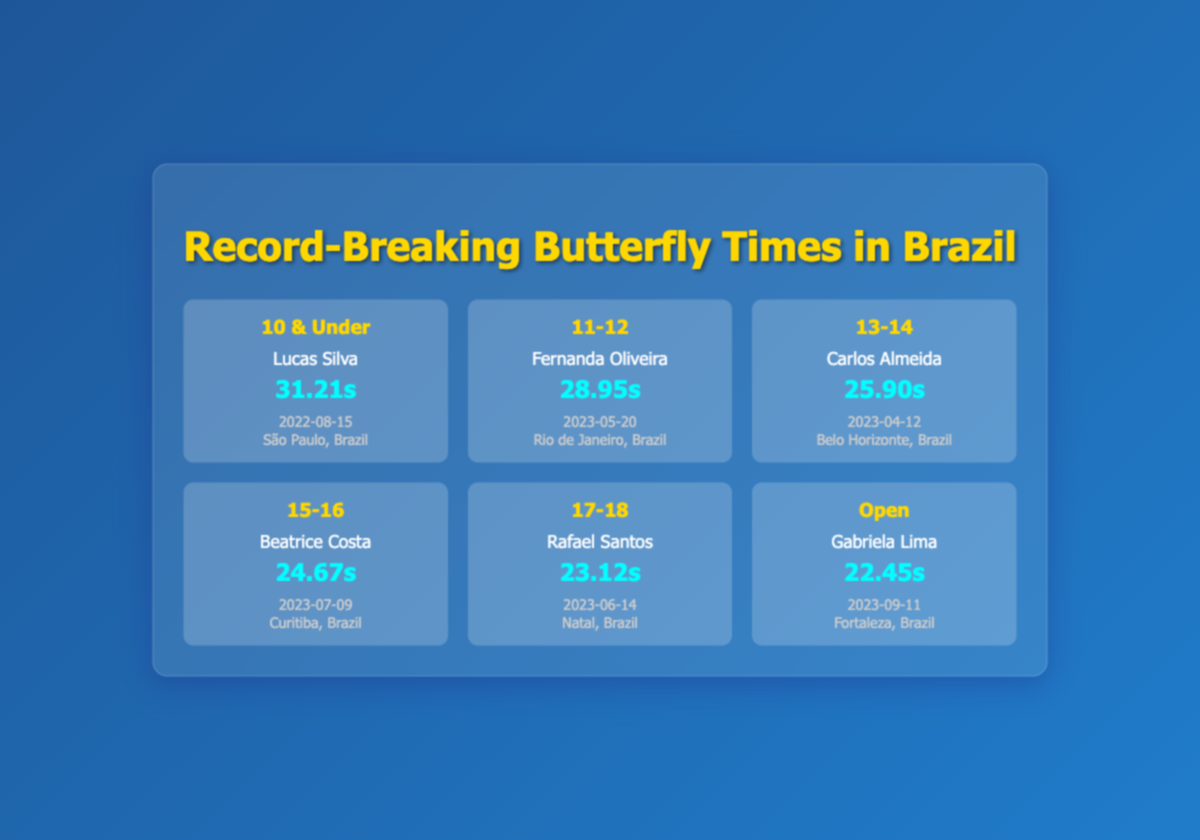What is the record time for the 10 & Under age category? The table shows that the record time for the 10 & Under age category is 31.21 seconds. This information is explicitly stated in the record for Lucas Silva.
Answer: 31.21 seconds Who holds the record for the Open age category? According to the table, Gabriela Lima holds the record for the Open age category. This is clearly indicated under the respective row for that age category.
Answer: Gabriela Lima What is the difference in record times between the 15-16 and 17-18 age categories? The record time for the 15-16 age category is 24.67 seconds, and for the 17-18 age category, it is 23.12 seconds. The difference is calculated by subtracting the latter from the former: 24.67 - 23.12 = 1.55 seconds.
Answer: 1.55 seconds Is the record time for the 11-12 age category faster than that of the 13-14 age category? The table indicates that the record time for the 11-12 age category is 28.95 seconds, while for the 13-14 age category, it is 25.90 seconds. Since 28.95 seconds is greater than 25.90 seconds, the 11-12 age category record is not faster.
Answer: No What is the average record time across all age categories? First, we sum the record times of all categories: 31.21 + 28.95 + 25.90 + 24.67 + 23.12 + 22.45 = 156.30 seconds. Then, we divide by the number of categories, which is 6: 156.30 / 6 = 26.05 seconds.
Answer: 26.05 seconds Who has the fastest butterfly stroke record? The table shows that Gabriela Lima has the fastest record in the Open category with a time of 22.45 seconds, which is the lowest time listed in all categories.
Answer: Gabriela Lima What was the event date for Carlos Almeida’s record? The record for Carlos Almeida under the 13-14 age category states that the event date was 2023-04-12. This specific detail is directly available in the respective row.
Answer: 2023-04-12 Which event location had the fastest record time? By reviewing the table, Gabriela Lima’s record of 22.45 seconds is the fastest and occurred in Fortaleza, Brazil. This location is associated with the fastest record time.
Answer: Fortaleza, Brazil Do any records appear to have been set in the same location? Upon examining the table, there are no repeating event locations with differing records. Each age category record was set in a unique location.
Answer: No 